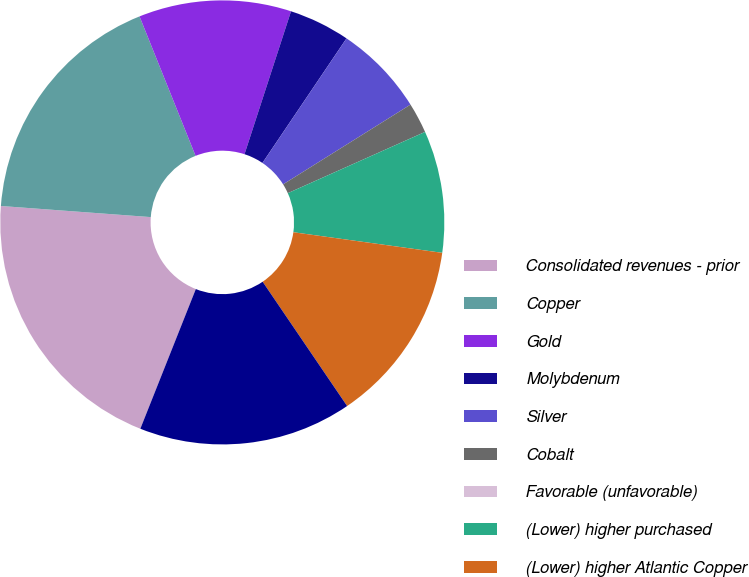Convert chart. <chart><loc_0><loc_0><loc_500><loc_500><pie_chart><fcel>Consolidated revenues - prior<fcel>Copper<fcel>Gold<fcel>Molybdenum<fcel>Silver<fcel>Cobalt<fcel>Favorable (unfavorable)<fcel>(Lower) higher purchased<fcel>(Lower) higher Atlantic Copper<fcel>Other including intercompany<nl><fcel>20.16%<fcel>17.74%<fcel>11.09%<fcel>4.44%<fcel>6.65%<fcel>2.22%<fcel>0.0%<fcel>8.87%<fcel>13.31%<fcel>15.52%<nl></chart> 